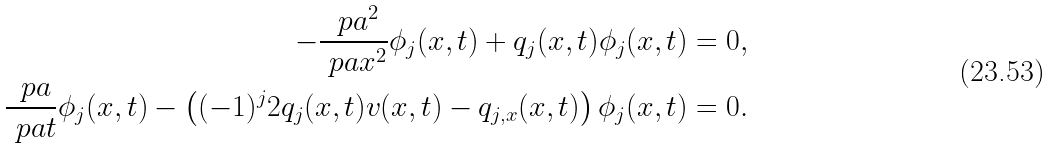Convert formula to latex. <formula><loc_0><loc_0><loc_500><loc_500>- \frac { \ p a ^ { 2 } } { \ p a x ^ { 2 } } \phi _ { j } ( x , t ) + q _ { j } ( x , t ) \phi _ { j } ( x , t ) & = 0 , \\ \frac { \ p a } { \ p a t } \phi _ { j } ( x , t ) - \left ( ( - 1 ) ^ { j } 2 q _ { j } ( x , t ) v ( x , t ) - q _ { j , x } ( x , t ) \right ) \phi _ { j } ( x , t ) & = 0 .</formula> 